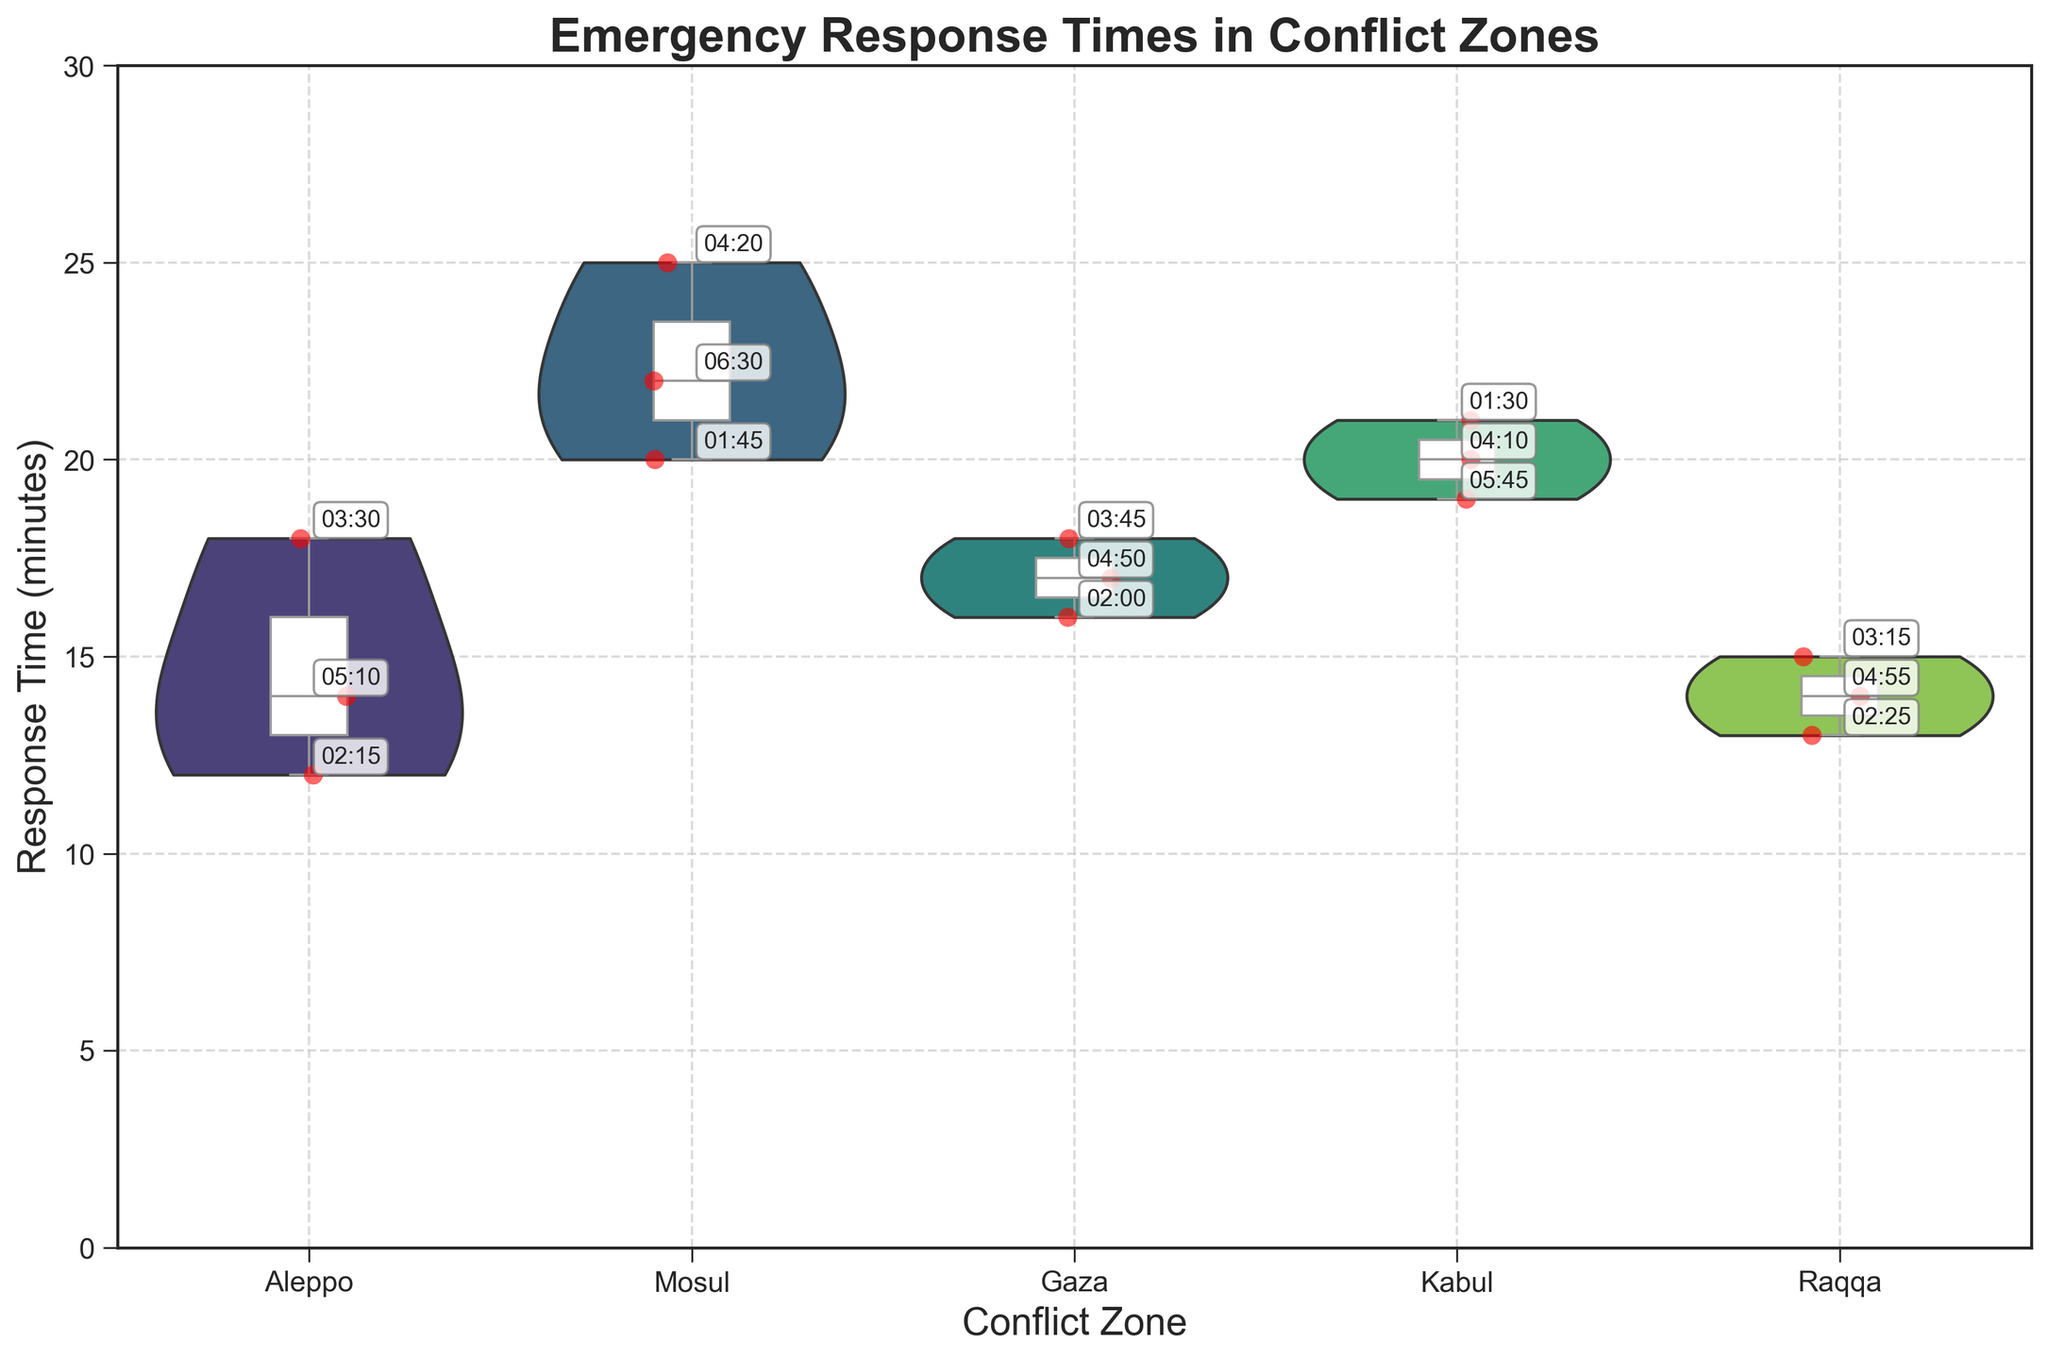What is the title of the figure? The title of the figure is displayed at the top in large, bold font, making it easy to identify.
Answer: Emergency Response Times in Conflict Zones How many conflict zones are illustrated in the figure? The x-axis labels represent different conflict zones. Counting these labels will give the number of conflict zones.
Answer: 5 What is the range of response times in the Mosul conflict zone? Observing the vertical spread of the data points in the Mosul section will provide the range of response times. The box plot and whiskers help visualize the minimum and maximum values.
Answer: 20 to 25 minutes Which conflict zone shows the highest median response time? The horizontal line inside each box plot represents the median response time. By comparing these lines across all conflict zones, we can identify the one with the highest median value.
Answer: Mosul How do the response times in Aleppo compare to those in Kabul? By comparing the violin plot widths and the positions of the box plots in the Aleppo and Kabul sections, insights on the distribution and median response times can be deduced.
Answer: Aleppo generally has shorter response times than Kabul Which conflict zone has the most consistent response times, and how can you tell? Consistent response times are indicated by a smaller interquartile range in the box plot and a tighter spread of the violin plot within each conflict zone.
Answer: Raqqa, as it has the narrowest interquartile range and a concentrated violin plot What's the difference between the longest response time in Gaza and the shortest response time in Mosul? To find this, identify the maximum response time in Gaza and the minimum response time in Mosul, then calculate the difference.
Answer: 25 - 16 = 9 minutes What is the average of the median response times across all conflict zones? Calculate the median response time for each conflict zone from the horizontal lines in the box plots, sum these medians, and divide by the number of conflict zones.
Answer: (14 + 20 + 17 + 19 + 14) / 5 = 16.8 minutes Which conflict zone has a response time with the largest range and what is the value of that range? The conflict zone with the largest range will have the widest spread between the minimum and maximum values in its box plot. Subtract the minimum value from the maximum value in that zone.
Answer: Mosul, 25 - 20 = 5 minutes 